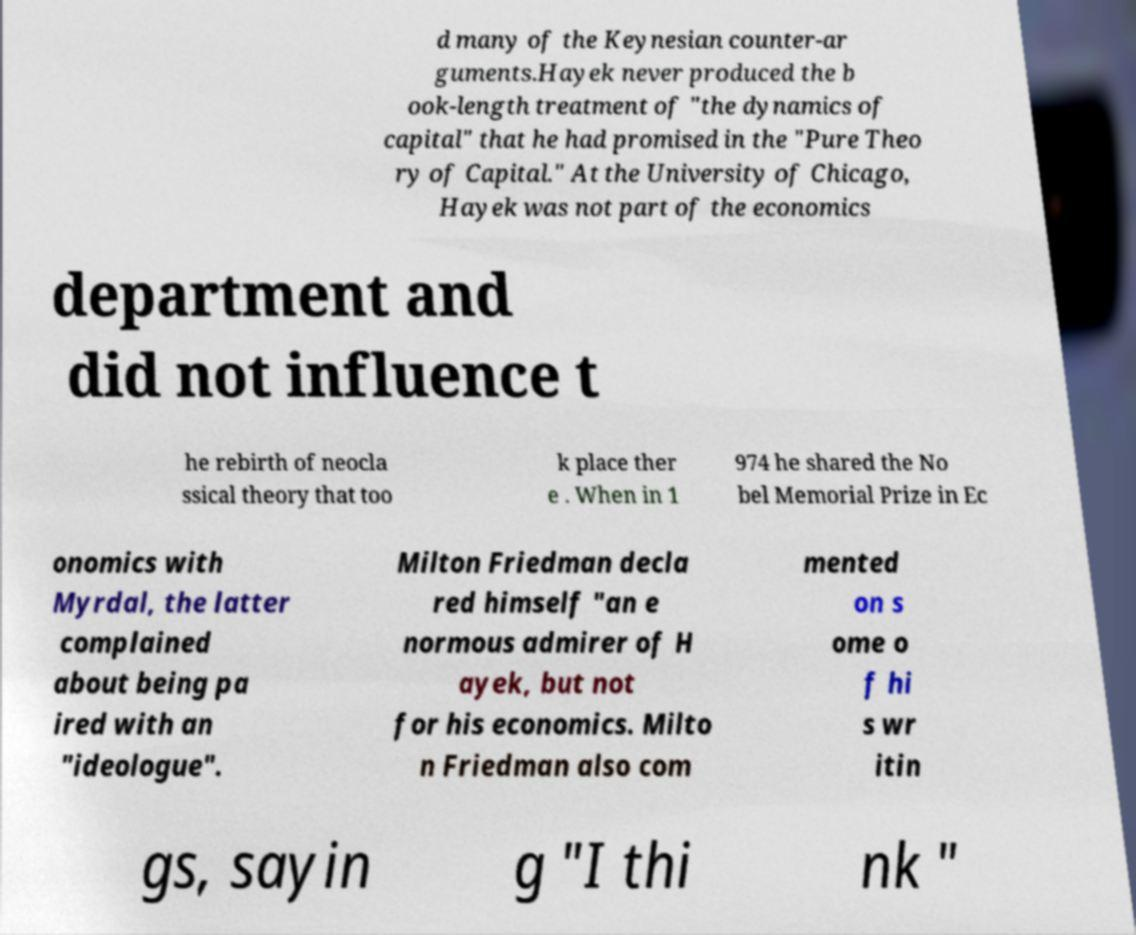Can you read and provide the text displayed in the image?This photo seems to have some interesting text. Can you extract and type it out for me? d many of the Keynesian counter-ar guments.Hayek never produced the b ook-length treatment of "the dynamics of capital" that he had promised in the "Pure Theo ry of Capital." At the University of Chicago, Hayek was not part of the economics department and did not influence t he rebirth of neocla ssical theory that too k place ther e . When in 1 974 he shared the No bel Memorial Prize in Ec onomics with Myrdal, the latter complained about being pa ired with an "ideologue". Milton Friedman decla red himself "an e normous admirer of H ayek, but not for his economics. Milto n Friedman also com mented on s ome o f hi s wr itin gs, sayin g "I thi nk " 